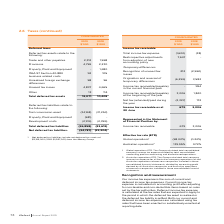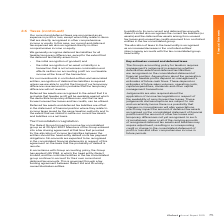According to Iselect's financial document, When is the recognition of deferred tax liabilities not required? we are able to control the timing of our temporary difference reversal and it is probable that the temporary difference will not reverse. The document states: "on of deferred tax liabilities is required unless we are able to control the timing of our temporary difference reversal and it is probable that the t..." Also, What does the net deferred tax liabilities include? net deferred tax assets of $2,195,000 (2018: $1,937,000) from the iMoney Group. The document states: "1 Net deferred tax liabilities include net deferred tax assets of $2,195,000 (2018: $1,937,000) from the iMoney Group...." Also, What is the total deferred tax assets in 2019? According to the financial document, 12,071 (in thousands). The relevant text states: "Total deferred tax assets 12,071 10,408..." Additionally, In which year is there a higher total deferred tax assets? According to the financial document, 2019. The relevant text states: "2019 $’000 2018 $’000..." Additionally, In which year is the net deferred tax liabilities higher? According to the financial document, 2019. The relevant text states: "2019 $’000 2018 $’000..." Also, can you calculate: What is the percentage change in the net deferred tax liabilities from 2018 to 2019? To answer this question, I need to perform calculations using the financial data. The calculation is: (24,787-23,204)/23,204, which equals 6.82 (percentage). This is based on the information: "Net deferred tax liabilities 1 (24,787) (23,204) Net deferred tax liabilities 1 (24,787) (23,204)..." The key data points involved are: 23,204, 24,787. 